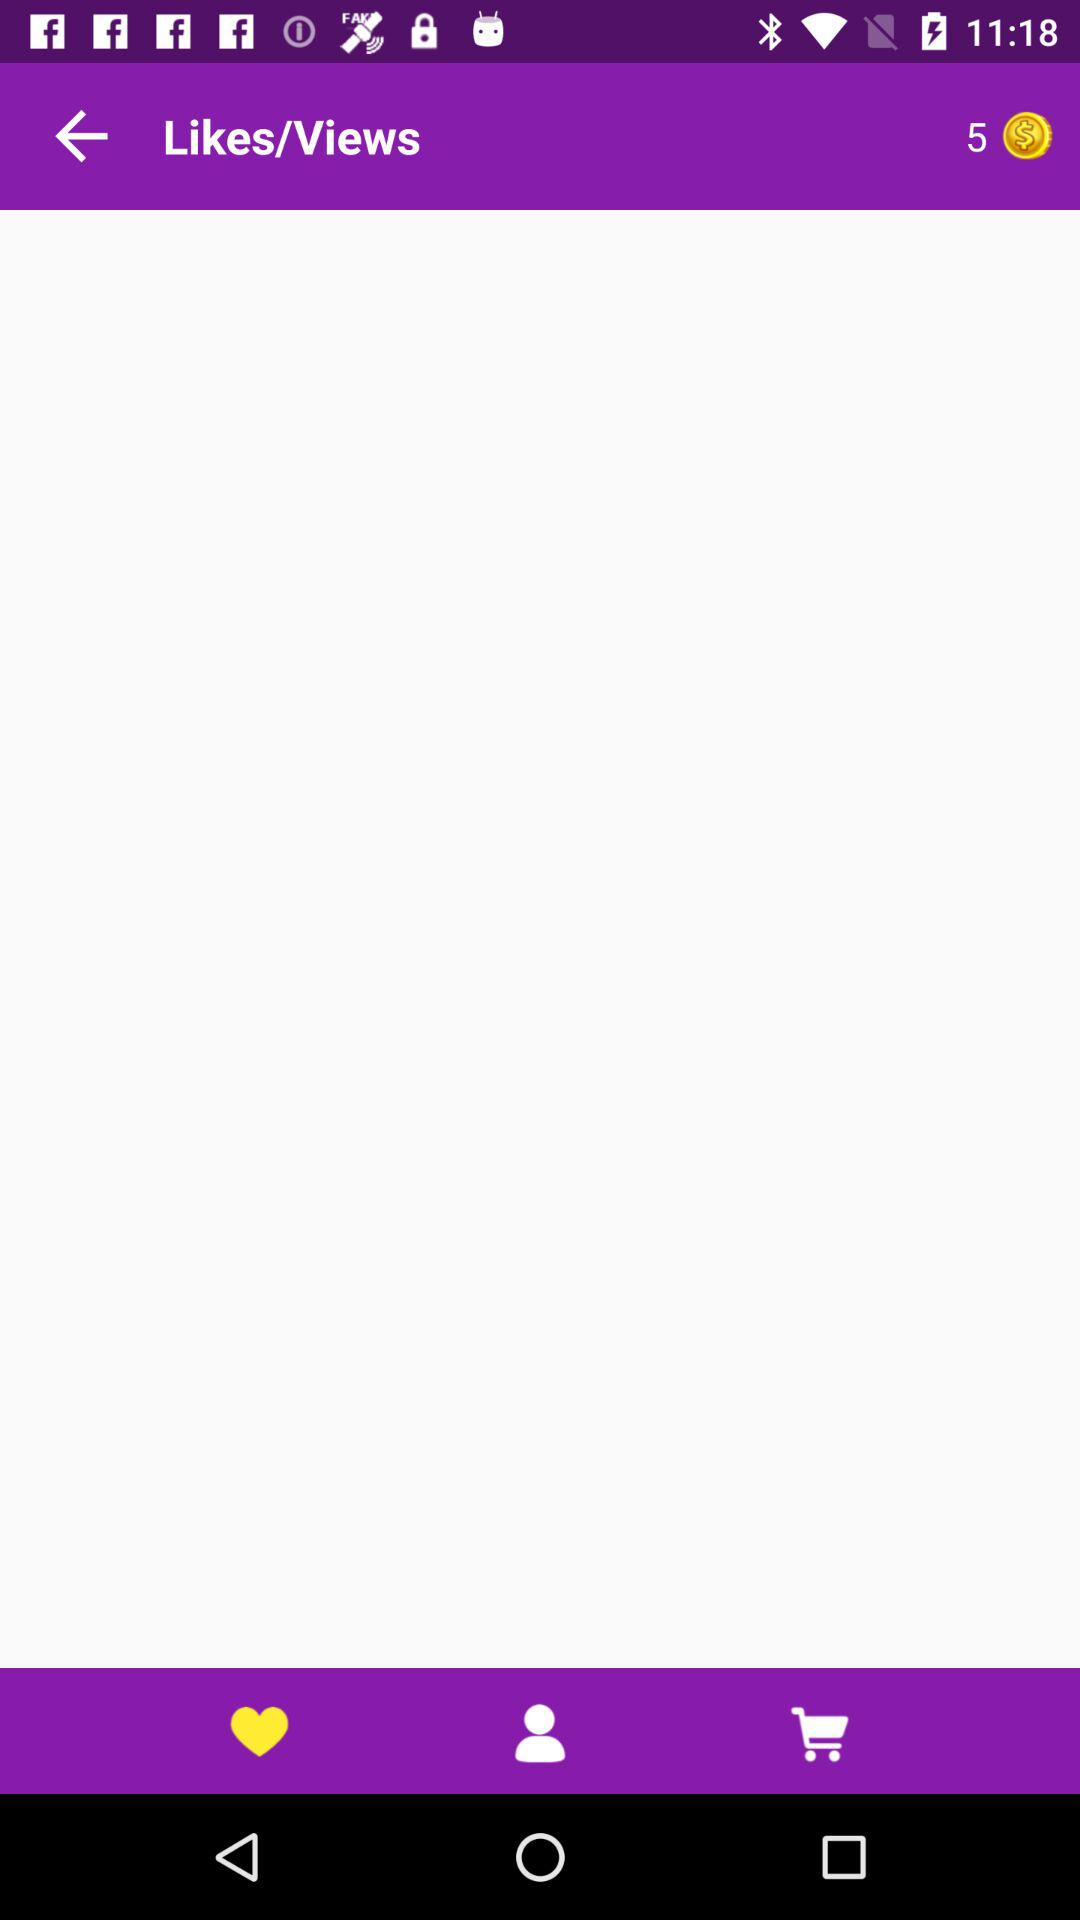What is the selected tab? The selected tab is "Likes/Views". 